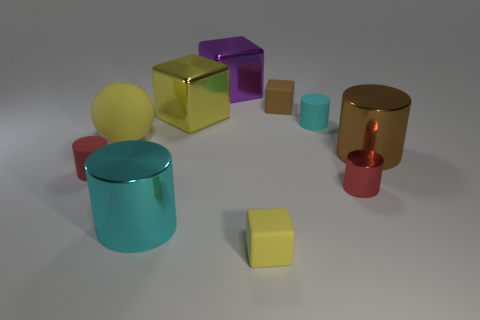Subtract all brown cylinders. How many cylinders are left? 4 Subtract all big brown cylinders. How many cylinders are left? 4 Subtract all gray cylinders. Subtract all cyan spheres. How many cylinders are left? 5 Subtract all balls. How many objects are left? 9 Add 1 matte cylinders. How many matte cylinders are left? 3 Add 5 yellow rubber blocks. How many yellow rubber blocks exist? 6 Subtract 0 yellow cylinders. How many objects are left? 10 Subtract all tiny brown shiny objects. Subtract all big metal things. How many objects are left? 6 